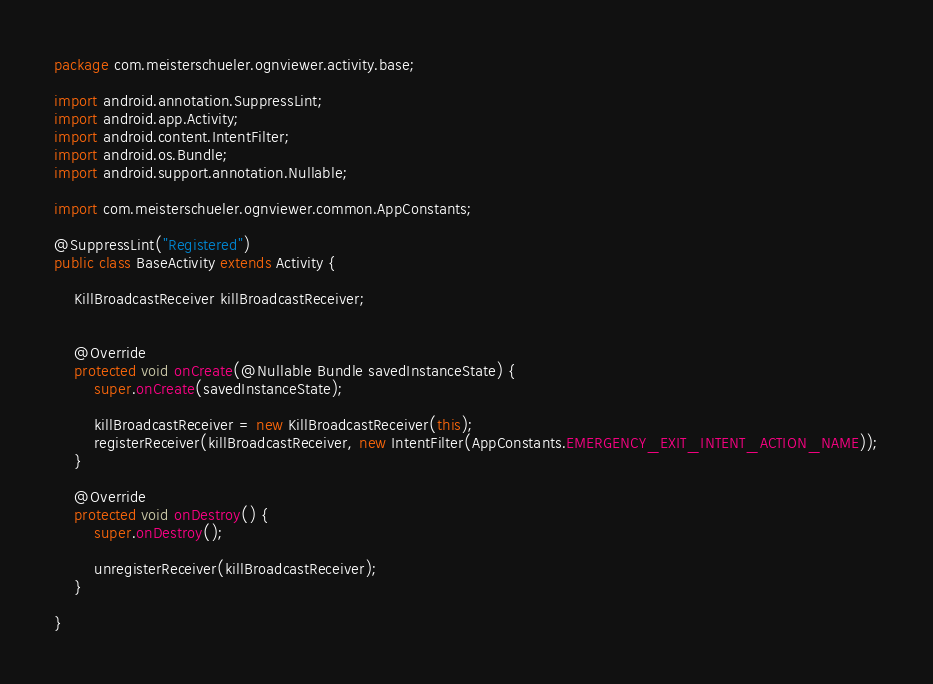Convert code to text. <code><loc_0><loc_0><loc_500><loc_500><_Java_>package com.meisterschueler.ognviewer.activity.base;

import android.annotation.SuppressLint;
import android.app.Activity;
import android.content.IntentFilter;
import android.os.Bundle;
import android.support.annotation.Nullable;

import com.meisterschueler.ognviewer.common.AppConstants;

@SuppressLint("Registered")
public class BaseActivity extends Activity {

    KillBroadcastReceiver killBroadcastReceiver;


    @Override
    protected void onCreate(@Nullable Bundle savedInstanceState) {
        super.onCreate(savedInstanceState);

        killBroadcastReceiver = new KillBroadcastReceiver(this);
        registerReceiver(killBroadcastReceiver, new IntentFilter(AppConstants.EMERGENCY_EXIT_INTENT_ACTION_NAME));
    }

    @Override
    protected void onDestroy() {
        super.onDestroy();

        unregisterReceiver(killBroadcastReceiver);
    }

}
</code> 